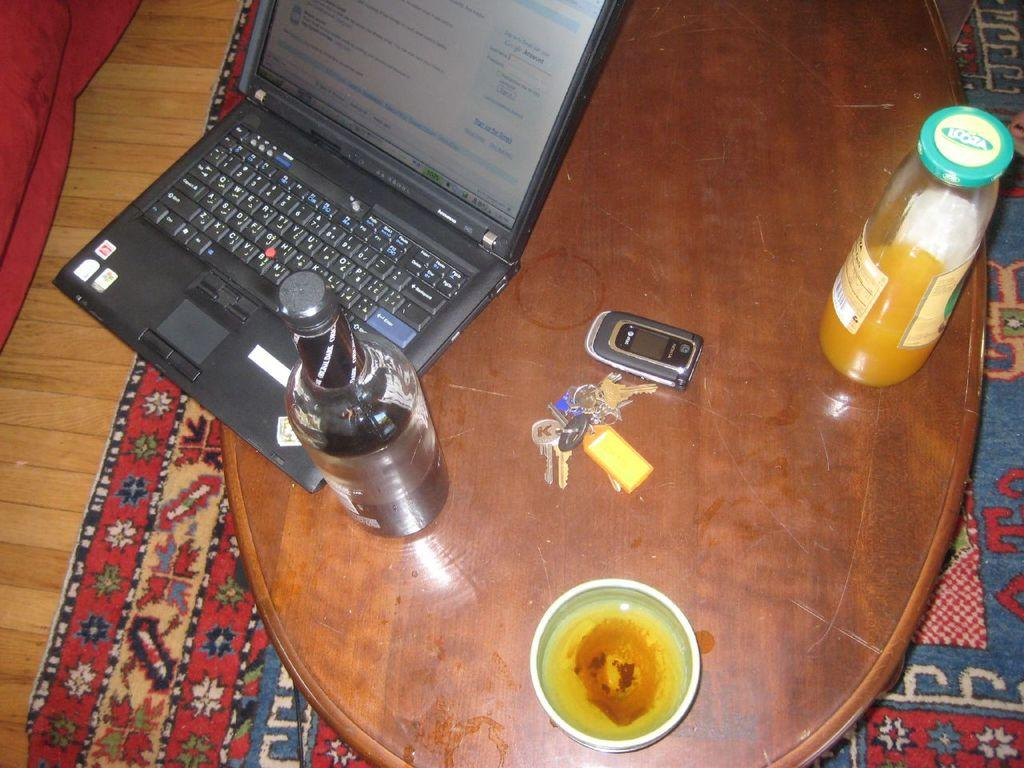What type of surface is visible in the image? There is a wooden surface in the image. What type of flooring is present in the image? There is a carpet in the image. What piece of furniture is in the image? There is a table in the image. What electronic device is on the table? There is a laptop on the table. What type of items are on the table? There are bottles, a gadget, keys, and a bowl on the table. Can you see any signs of hate in the image? There is no indication of hate in the image; it features a table with various objects on it. Is the seashore visible in the image? No, the seashore is not visible in the image; it features a table with various objects on it. 